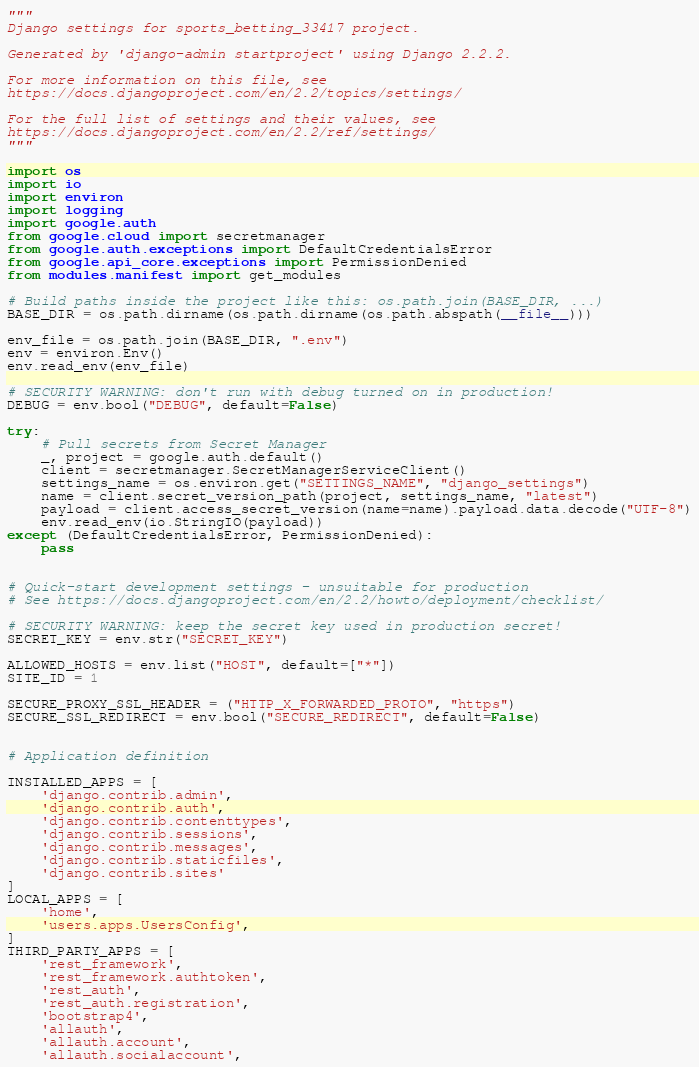<code> <loc_0><loc_0><loc_500><loc_500><_Python_>"""
Django settings for sports_betting_33417 project.

Generated by 'django-admin startproject' using Django 2.2.2.

For more information on this file, see
https://docs.djangoproject.com/en/2.2/topics/settings/

For the full list of settings and their values, see
https://docs.djangoproject.com/en/2.2/ref/settings/
"""

import os
import io
import environ
import logging
import google.auth
from google.cloud import secretmanager
from google.auth.exceptions import DefaultCredentialsError
from google.api_core.exceptions import PermissionDenied
from modules.manifest import get_modules

# Build paths inside the project like this: os.path.join(BASE_DIR, ...)
BASE_DIR = os.path.dirname(os.path.dirname(os.path.abspath(__file__)))

env_file = os.path.join(BASE_DIR, ".env")
env = environ.Env()
env.read_env(env_file)

# SECURITY WARNING: don't run with debug turned on in production!
DEBUG = env.bool("DEBUG", default=False)

try:
    # Pull secrets from Secret Manager
    _, project = google.auth.default()
    client = secretmanager.SecretManagerServiceClient()
    settings_name = os.environ.get("SETTINGS_NAME", "django_settings")
    name = client.secret_version_path(project, settings_name, "latest")
    payload = client.access_secret_version(name=name).payload.data.decode("UTF-8")
    env.read_env(io.StringIO(payload))
except (DefaultCredentialsError, PermissionDenied):
    pass


# Quick-start development settings - unsuitable for production
# See https://docs.djangoproject.com/en/2.2/howto/deployment/checklist/

# SECURITY WARNING: keep the secret key used in production secret!
SECRET_KEY = env.str("SECRET_KEY")

ALLOWED_HOSTS = env.list("HOST", default=["*"])
SITE_ID = 1

SECURE_PROXY_SSL_HEADER = ("HTTP_X_FORWARDED_PROTO", "https")
SECURE_SSL_REDIRECT = env.bool("SECURE_REDIRECT", default=False)


# Application definition

INSTALLED_APPS = [
    'django.contrib.admin',
    'django.contrib.auth',
    'django.contrib.contenttypes',
    'django.contrib.sessions',
    'django.contrib.messages',
    'django.contrib.staticfiles',
    'django.contrib.sites'
]
LOCAL_APPS = [
    'home',
    'users.apps.UsersConfig',
]
THIRD_PARTY_APPS = [
    'rest_framework',
    'rest_framework.authtoken',
    'rest_auth',
    'rest_auth.registration',
    'bootstrap4',
    'allauth',
    'allauth.account',
    'allauth.socialaccount',</code> 